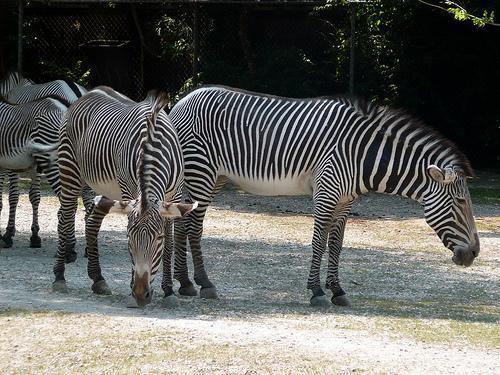How many zebras?
Give a very brief answer. 4. 